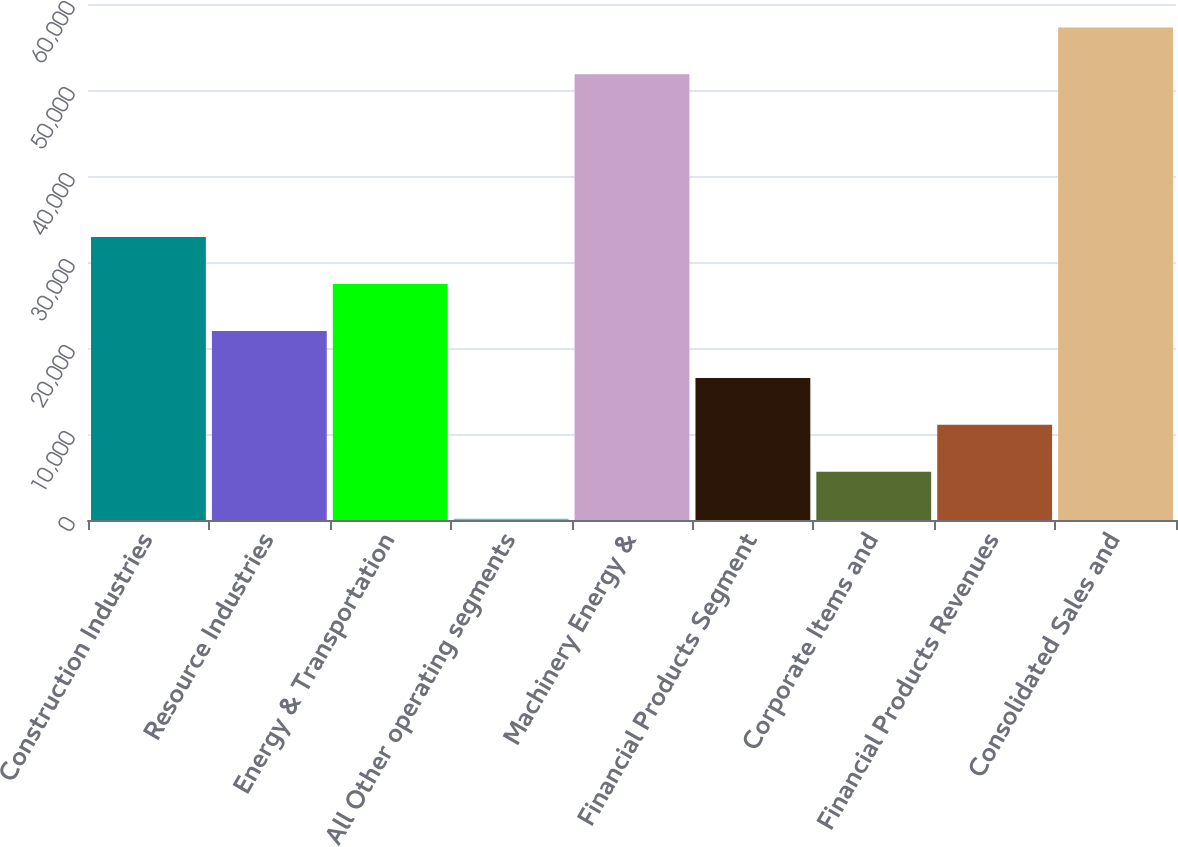<chart> <loc_0><loc_0><loc_500><loc_500><bar_chart><fcel>Construction Industries<fcel>Resource Industries<fcel>Energy & Transportation<fcel>All Other operating segments<fcel>Machinery Energy &<fcel>Financial Products Segment<fcel>Corporate Items and<fcel>Financial Products Revenues<fcel>Consolidated Sales and<nl><fcel>32894.8<fcel>21981.2<fcel>27438<fcel>154<fcel>51822<fcel>16524.4<fcel>5610.8<fcel>11067.6<fcel>57278.8<nl></chart> 